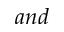Convert formula to latex. <formula><loc_0><loc_0><loc_500><loc_500>a n d</formula> 